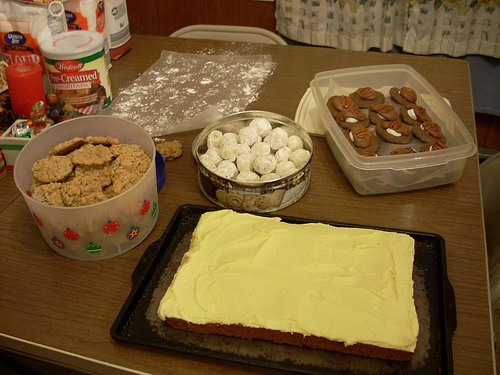<image>
Is there a can on the table? Yes. Looking at the image, I can see the can is positioned on top of the table, with the table providing support. 